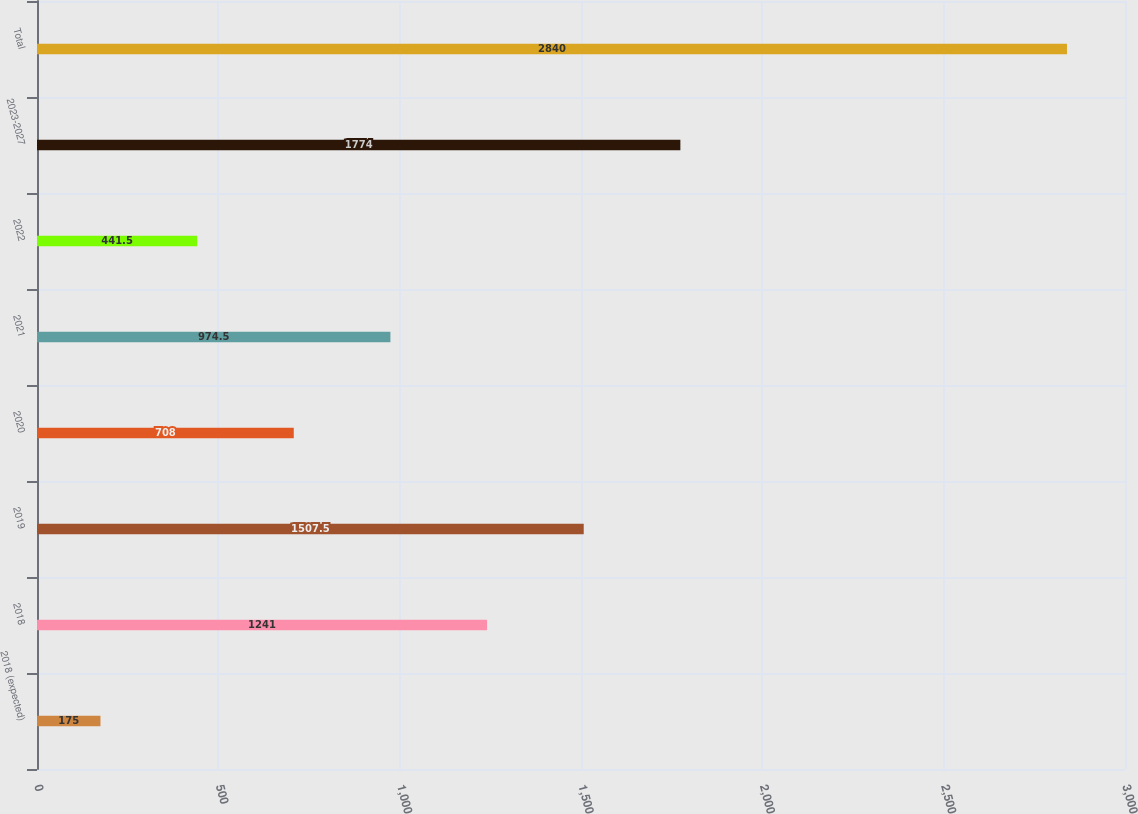<chart> <loc_0><loc_0><loc_500><loc_500><bar_chart><fcel>2018 (expected)<fcel>2018<fcel>2019<fcel>2020<fcel>2021<fcel>2022<fcel>2023-2027<fcel>Total<nl><fcel>175<fcel>1241<fcel>1507.5<fcel>708<fcel>974.5<fcel>441.5<fcel>1774<fcel>2840<nl></chart> 